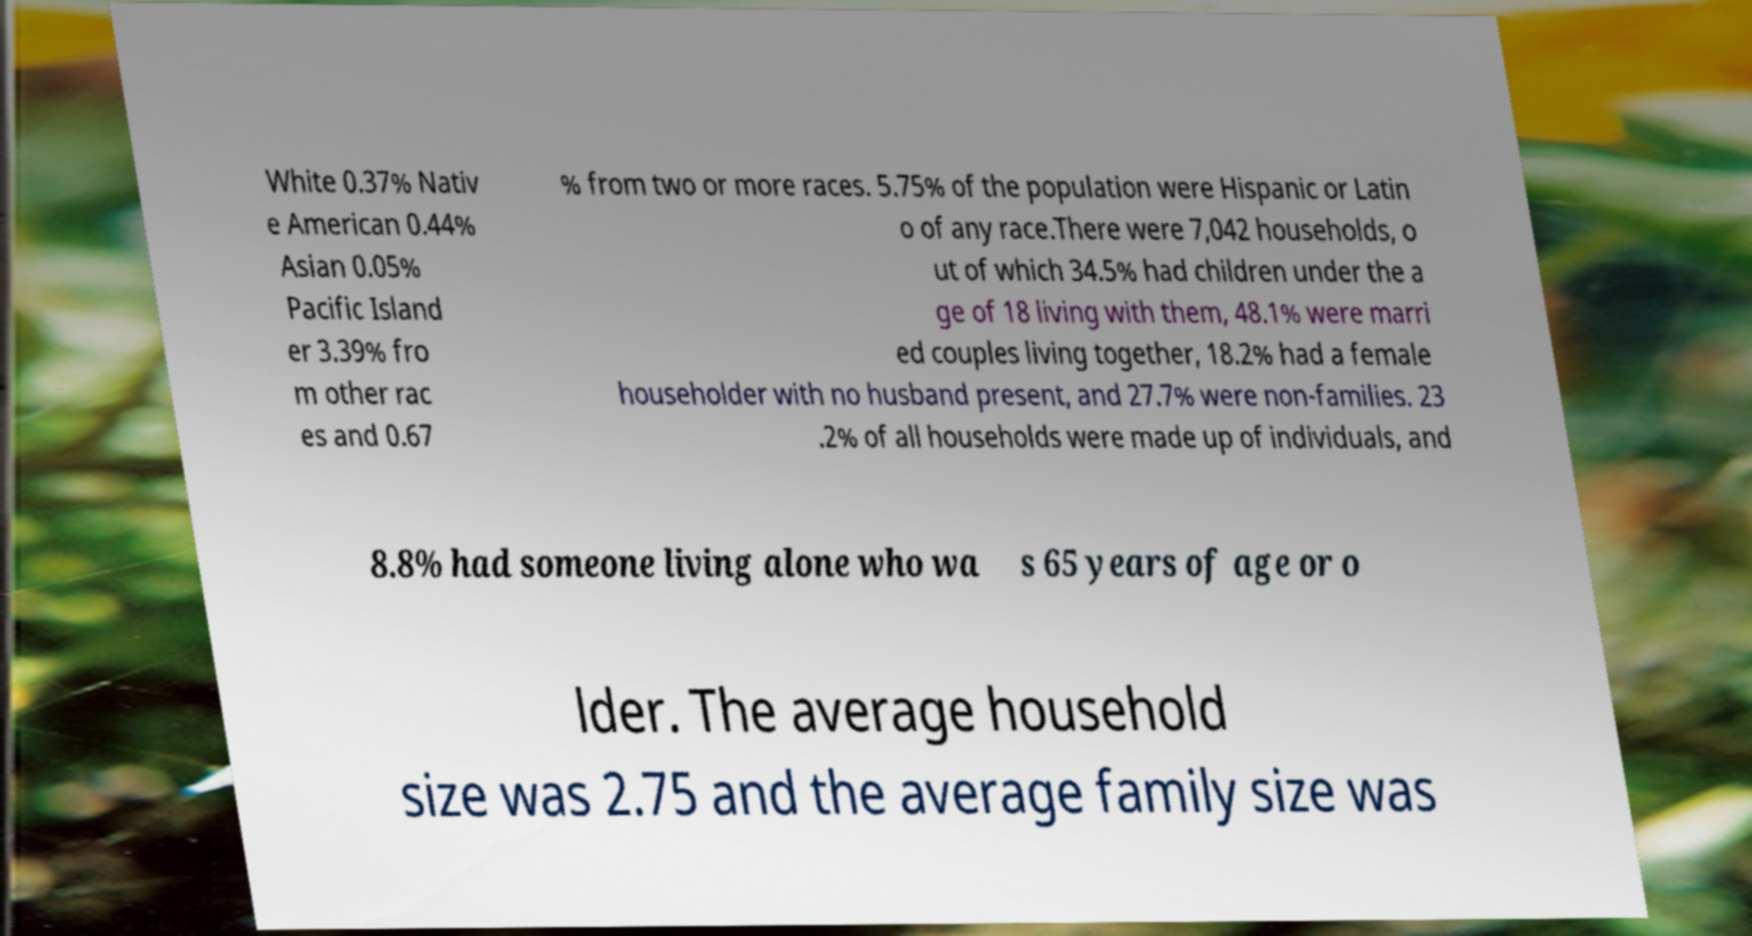For documentation purposes, I need the text within this image transcribed. Could you provide that? White 0.37% Nativ e American 0.44% Asian 0.05% Pacific Island er 3.39% fro m other rac es and 0.67 % from two or more races. 5.75% of the population were Hispanic or Latin o of any race.There were 7,042 households, o ut of which 34.5% had children under the a ge of 18 living with them, 48.1% were marri ed couples living together, 18.2% had a female householder with no husband present, and 27.7% were non-families. 23 .2% of all households were made up of individuals, and 8.8% had someone living alone who wa s 65 years of age or o lder. The average household size was 2.75 and the average family size was 